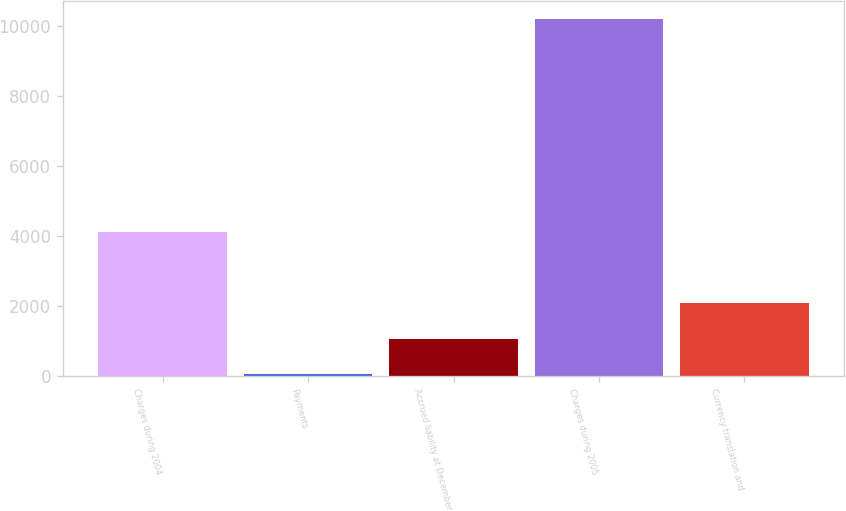Convert chart. <chart><loc_0><loc_0><loc_500><loc_500><bar_chart><fcel>Charges during 2004<fcel>Payments<fcel>Accrued liability at December<fcel>Charges during 2005<fcel>Currency translation and<nl><fcel>4103<fcel>35<fcel>1052<fcel>10205<fcel>2069<nl></chart> 